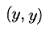Convert formula to latex. <formula><loc_0><loc_0><loc_500><loc_500>( y , y )</formula> 